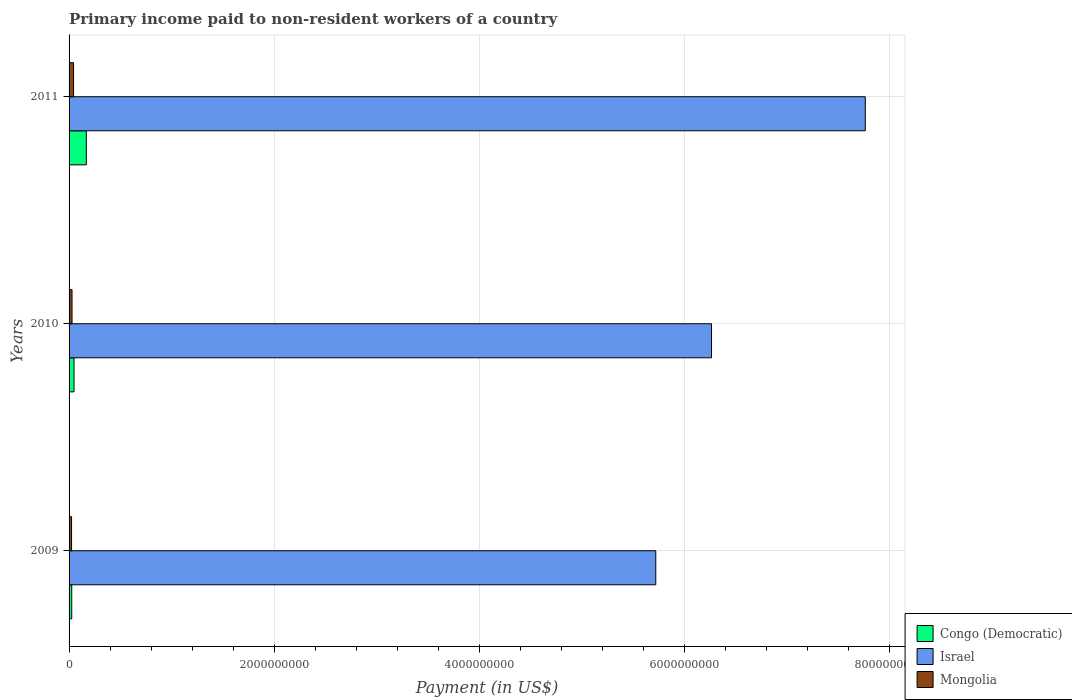How many different coloured bars are there?
Your answer should be very brief. 3. Are the number of bars per tick equal to the number of legend labels?
Ensure brevity in your answer.  Yes. Are the number of bars on each tick of the Y-axis equal?
Offer a terse response. Yes. How many bars are there on the 2nd tick from the top?
Make the answer very short. 3. What is the amount paid to workers in Mongolia in 2011?
Your answer should be compact. 4.37e+07. Across all years, what is the maximum amount paid to workers in Mongolia?
Ensure brevity in your answer.  4.37e+07. Across all years, what is the minimum amount paid to workers in Mongolia?
Provide a succinct answer. 2.43e+07. In which year was the amount paid to workers in Israel minimum?
Ensure brevity in your answer.  2009. What is the total amount paid to workers in Israel in the graph?
Ensure brevity in your answer.  1.98e+1. What is the difference between the amount paid to workers in Israel in 2009 and that in 2010?
Make the answer very short. -5.44e+08. What is the difference between the amount paid to workers in Israel in 2010 and the amount paid to workers in Congo (Democratic) in 2009?
Offer a terse response. 6.24e+09. What is the average amount paid to workers in Mongolia per year?
Provide a succinct answer. 3.23e+07. In the year 2010, what is the difference between the amount paid to workers in Israel and amount paid to workers in Congo (Democratic)?
Make the answer very short. 6.22e+09. In how many years, is the amount paid to workers in Israel greater than 4400000000 US$?
Provide a short and direct response. 3. What is the ratio of the amount paid to workers in Congo (Democratic) in 2010 to that in 2011?
Make the answer very short. 0.29. Is the amount paid to workers in Congo (Democratic) in 2009 less than that in 2011?
Make the answer very short. Yes. What is the difference between the highest and the second highest amount paid to workers in Israel?
Provide a short and direct response. 1.50e+09. What is the difference between the highest and the lowest amount paid to workers in Israel?
Give a very brief answer. 2.04e+09. In how many years, is the amount paid to workers in Israel greater than the average amount paid to workers in Israel taken over all years?
Provide a short and direct response. 1. Is the sum of the amount paid to workers in Congo (Democratic) in 2009 and 2010 greater than the maximum amount paid to workers in Israel across all years?
Provide a succinct answer. No. What does the 3rd bar from the top in 2010 represents?
Make the answer very short. Congo (Democratic). What does the 3rd bar from the bottom in 2010 represents?
Offer a very short reply. Mongolia. How many bars are there?
Your answer should be very brief. 9. How many years are there in the graph?
Give a very brief answer. 3. Does the graph contain grids?
Ensure brevity in your answer.  Yes. Where does the legend appear in the graph?
Keep it short and to the point. Bottom right. What is the title of the graph?
Your answer should be compact. Primary income paid to non-resident workers of a country. Does "Macao" appear as one of the legend labels in the graph?
Keep it short and to the point. No. What is the label or title of the X-axis?
Ensure brevity in your answer.  Payment (in US$). What is the label or title of the Y-axis?
Make the answer very short. Years. What is the Payment (in US$) of Congo (Democratic) in 2009?
Your response must be concise. 2.60e+07. What is the Payment (in US$) of Israel in 2009?
Offer a very short reply. 5.72e+09. What is the Payment (in US$) in Mongolia in 2009?
Your answer should be compact. 2.43e+07. What is the Payment (in US$) of Congo (Democratic) in 2010?
Offer a terse response. 4.83e+07. What is the Payment (in US$) of Israel in 2010?
Your answer should be very brief. 6.27e+09. What is the Payment (in US$) in Mongolia in 2010?
Offer a very short reply. 2.89e+07. What is the Payment (in US$) of Congo (Democratic) in 2011?
Make the answer very short. 1.68e+08. What is the Payment (in US$) in Israel in 2011?
Provide a succinct answer. 7.77e+09. What is the Payment (in US$) of Mongolia in 2011?
Offer a very short reply. 4.37e+07. Across all years, what is the maximum Payment (in US$) of Congo (Democratic)?
Offer a terse response. 1.68e+08. Across all years, what is the maximum Payment (in US$) in Israel?
Keep it short and to the point. 7.77e+09. Across all years, what is the maximum Payment (in US$) in Mongolia?
Keep it short and to the point. 4.37e+07. Across all years, what is the minimum Payment (in US$) in Congo (Democratic)?
Your answer should be very brief. 2.60e+07. Across all years, what is the minimum Payment (in US$) in Israel?
Offer a very short reply. 5.72e+09. Across all years, what is the minimum Payment (in US$) of Mongolia?
Make the answer very short. 2.43e+07. What is the total Payment (in US$) in Congo (Democratic) in the graph?
Your response must be concise. 2.42e+08. What is the total Payment (in US$) of Israel in the graph?
Your response must be concise. 1.98e+1. What is the total Payment (in US$) in Mongolia in the graph?
Offer a very short reply. 9.70e+07. What is the difference between the Payment (in US$) of Congo (Democratic) in 2009 and that in 2010?
Your response must be concise. -2.23e+07. What is the difference between the Payment (in US$) in Israel in 2009 and that in 2010?
Make the answer very short. -5.44e+08. What is the difference between the Payment (in US$) in Mongolia in 2009 and that in 2010?
Ensure brevity in your answer.  -4.60e+06. What is the difference between the Payment (in US$) in Congo (Democratic) in 2009 and that in 2011?
Ensure brevity in your answer.  -1.42e+08. What is the difference between the Payment (in US$) of Israel in 2009 and that in 2011?
Your answer should be very brief. -2.04e+09. What is the difference between the Payment (in US$) of Mongolia in 2009 and that in 2011?
Provide a short and direct response. -1.94e+07. What is the difference between the Payment (in US$) in Congo (Democratic) in 2010 and that in 2011?
Your answer should be very brief. -1.20e+08. What is the difference between the Payment (in US$) in Israel in 2010 and that in 2011?
Give a very brief answer. -1.50e+09. What is the difference between the Payment (in US$) in Mongolia in 2010 and that in 2011?
Your answer should be compact. -1.48e+07. What is the difference between the Payment (in US$) of Congo (Democratic) in 2009 and the Payment (in US$) of Israel in 2010?
Your answer should be very brief. -6.24e+09. What is the difference between the Payment (in US$) of Congo (Democratic) in 2009 and the Payment (in US$) of Mongolia in 2010?
Give a very brief answer. -2.92e+06. What is the difference between the Payment (in US$) in Israel in 2009 and the Payment (in US$) in Mongolia in 2010?
Keep it short and to the point. 5.69e+09. What is the difference between the Payment (in US$) of Congo (Democratic) in 2009 and the Payment (in US$) of Israel in 2011?
Your answer should be very brief. -7.74e+09. What is the difference between the Payment (in US$) of Congo (Democratic) in 2009 and the Payment (in US$) of Mongolia in 2011?
Your answer should be compact. -1.77e+07. What is the difference between the Payment (in US$) in Israel in 2009 and the Payment (in US$) in Mongolia in 2011?
Your answer should be very brief. 5.68e+09. What is the difference between the Payment (in US$) in Congo (Democratic) in 2010 and the Payment (in US$) in Israel in 2011?
Your answer should be compact. -7.72e+09. What is the difference between the Payment (in US$) in Congo (Democratic) in 2010 and the Payment (in US$) in Mongolia in 2011?
Your answer should be compact. 4.56e+06. What is the difference between the Payment (in US$) in Israel in 2010 and the Payment (in US$) in Mongolia in 2011?
Offer a very short reply. 6.22e+09. What is the average Payment (in US$) in Congo (Democratic) per year?
Provide a succinct answer. 8.08e+07. What is the average Payment (in US$) of Israel per year?
Provide a short and direct response. 6.58e+09. What is the average Payment (in US$) in Mongolia per year?
Provide a short and direct response. 3.23e+07. In the year 2009, what is the difference between the Payment (in US$) of Congo (Democratic) and Payment (in US$) of Israel?
Make the answer very short. -5.70e+09. In the year 2009, what is the difference between the Payment (in US$) of Congo (Democratic) and Payment (in US$) of Mongolia?
Ensure brevity in your answer.  1.68e+06. In the year 2009, what is the difference between the Payment (in US$) in Israel and Payment (in US$) in Mongolia?
Your answer should be compact. 5.70e+09. In the year 2010, what is the difference between the Payment (in US$) in Congo (Democratic) and Payment (in US$) in Israel?
Make the answer very short. -6.22e+09. In the year 2010, what is the difference between the Payment (in US$) in Congo (Democratic) and Payment (in US$) in Mongolia?
Offer a very short reply. 1.94e+07. In the year 2010, what is the difference between the Payment (in US$) of Israel and Payment (in US$) of Mongolia?
Your answer should be very brief. 6.24e+09. In the year 2011, what is the difference between the Payment (in US$) of Congo (Democratic) and Payment (in US$) of Israel?
Keep it short and to the point. -7.60e+09. In the year 2011, what is the difference between the Payment (in US$) of Congo (Democratic) and Payment (in US$) of Mongolia?
Ensure brevity in your answer.  1.24e+08. In the year 2011, what is the difference between the Payment (in US$) in Israel and Payment (in US$) in Mongolia?
Offer a very short reply. 7.72e+09. What is the ratio of the Payment (in US$) of Congo (Democratic) in 2009 to that in 2010?
Provide a succinct answer. 0.54. What is the ratio of the Payment (in US$) of Israel in 2009 to that in 2010?
Provide a succinct answer. 0.91. What is the ratio of the Payment (in US$) in Mongolia in 2009 to that in 2010?
Offer a very short reply. 0.84. What is the ratio of the Payment (in US$) of Congo (Democratic) in 2009 to that in 2011?
Give a very brief answer. 0.15. What is the ratio of the Payment (in US$) of Israel in 2009 to that in 2011?
Ensure brevity in your answer.  0.74. What is the ratio of the Payment (in US$) of Mongolia in 2009 to that in 2011?
Your answer should be compact. 0.56. What is the ratio of the Payment (in US$) in Congo (Democratic) in 2010 to that in 2011?
Offer a very short reply. 0.29. What is the ratio of the Payment (in US$) in Israel in 2010 to that in 2011?
Provide a short and direct response. 0.81. What is the ratio of the Payment (in US$) of Mongolia in 2010 to that in 2011?
Give a very brief answer. 0.66. What is the difference between the highest and the second highest Payment (in US$) in Congo (Democratic)?
Offer a very short reply. 1.20e+08. What is the difference between the highest and the second highest Payment (in US$) of Israel?
Your answer should be very brief. 1.50e+09. What is the difference between the highest and the second highest Payment (in US$) in Mongolia?
Your answer should be compact. 1.48e+07. What is the difference between the highest and the lowest Payment (in US$) of Congo (Democratic)?
Provide a succinct answer. 1.42e+08. What is the difference between the highest and the lowest Payment (in US$) of Israel?
Give a very brief answer. 2.04e+09. What is the difference between the highest and the lowest Payment (in US$) in Mongolia?
Your answer should be very brief. 1.94e+07. 